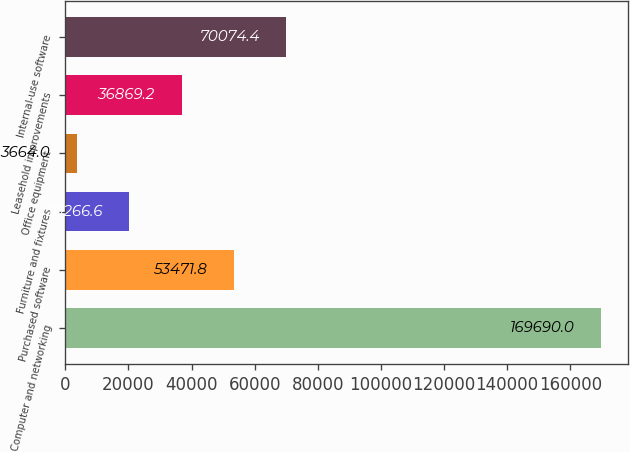Convert chart. <chart><loc_0><loc_0><loc_500><loc_500><bar_chart><fcel>Computer and networking<fcel>Purchased software<fcel>Furniture and fixtures<fcel>Office equipment<fcel>Leasehold improvements<fcel>Internal-use software<nl><fcel>169690<fcel>53471.8<fcel>20266.6<fcel>3664<fcel>36869.2<fcel>70074.4<nl></chart> 